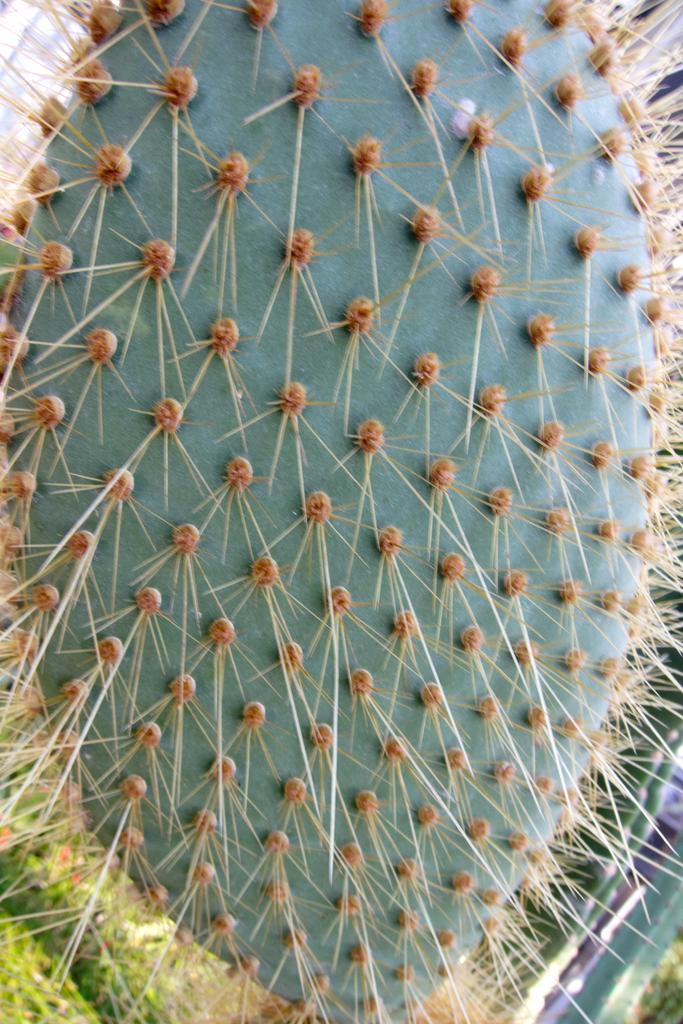Could you give a brief overview of what you see in this image? In this image there is a cactus plant. 